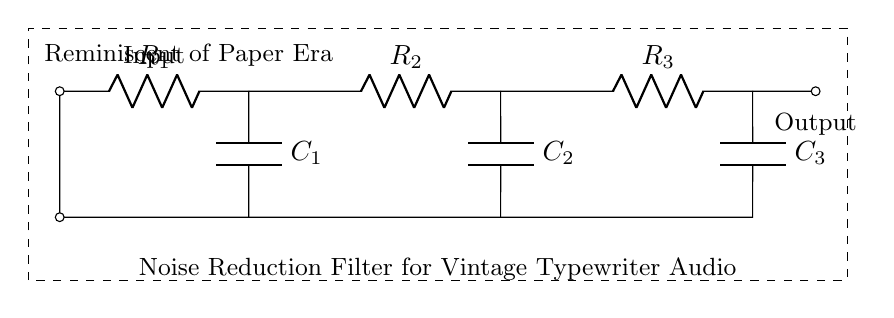What is the type of circuit shown? The circuit is a noise reduction filter, indicated by the label in the diagram. It specifically states that it is designed for vintage typewriter audio.
Answer: noise reduction filter How many resistors are in the circuit? By counting the components labeled as R, I identify three resistors present (R1, R2, R3) in the circuit diagram.
Answer: 3 What components are used in this filter circuit? The circuit includes resistors and capacitors, specifically three resistors (R1, R2, R3) and three capacitors (C1, C2, C3), which are explicitly labeled in the circuit.
Answer: resistors and capacitors What is the function of the capacitors in this circuit? Capacitors typically act to filter out high-frequency noise in such filters, as indicated by their arrangement in the circuit. This function is key for noise reduction.
Answer: filter high-frequency noise What is the overall purpose of this circuit? The circuit is labeled for noise reduction for vintage typewriter audio, indicating its purpose is to minimize unwanted noise from recordings of typewriters.
Answer: minimize noise in audio recordings What happens if one resistor is removed from the circuit? Removing a resistor could alter the current flowing through the circuit, affecting its overall resistance and possibly its filtering properties, which would need considering based on Ohm's law.
Answer: alters current and resistance 